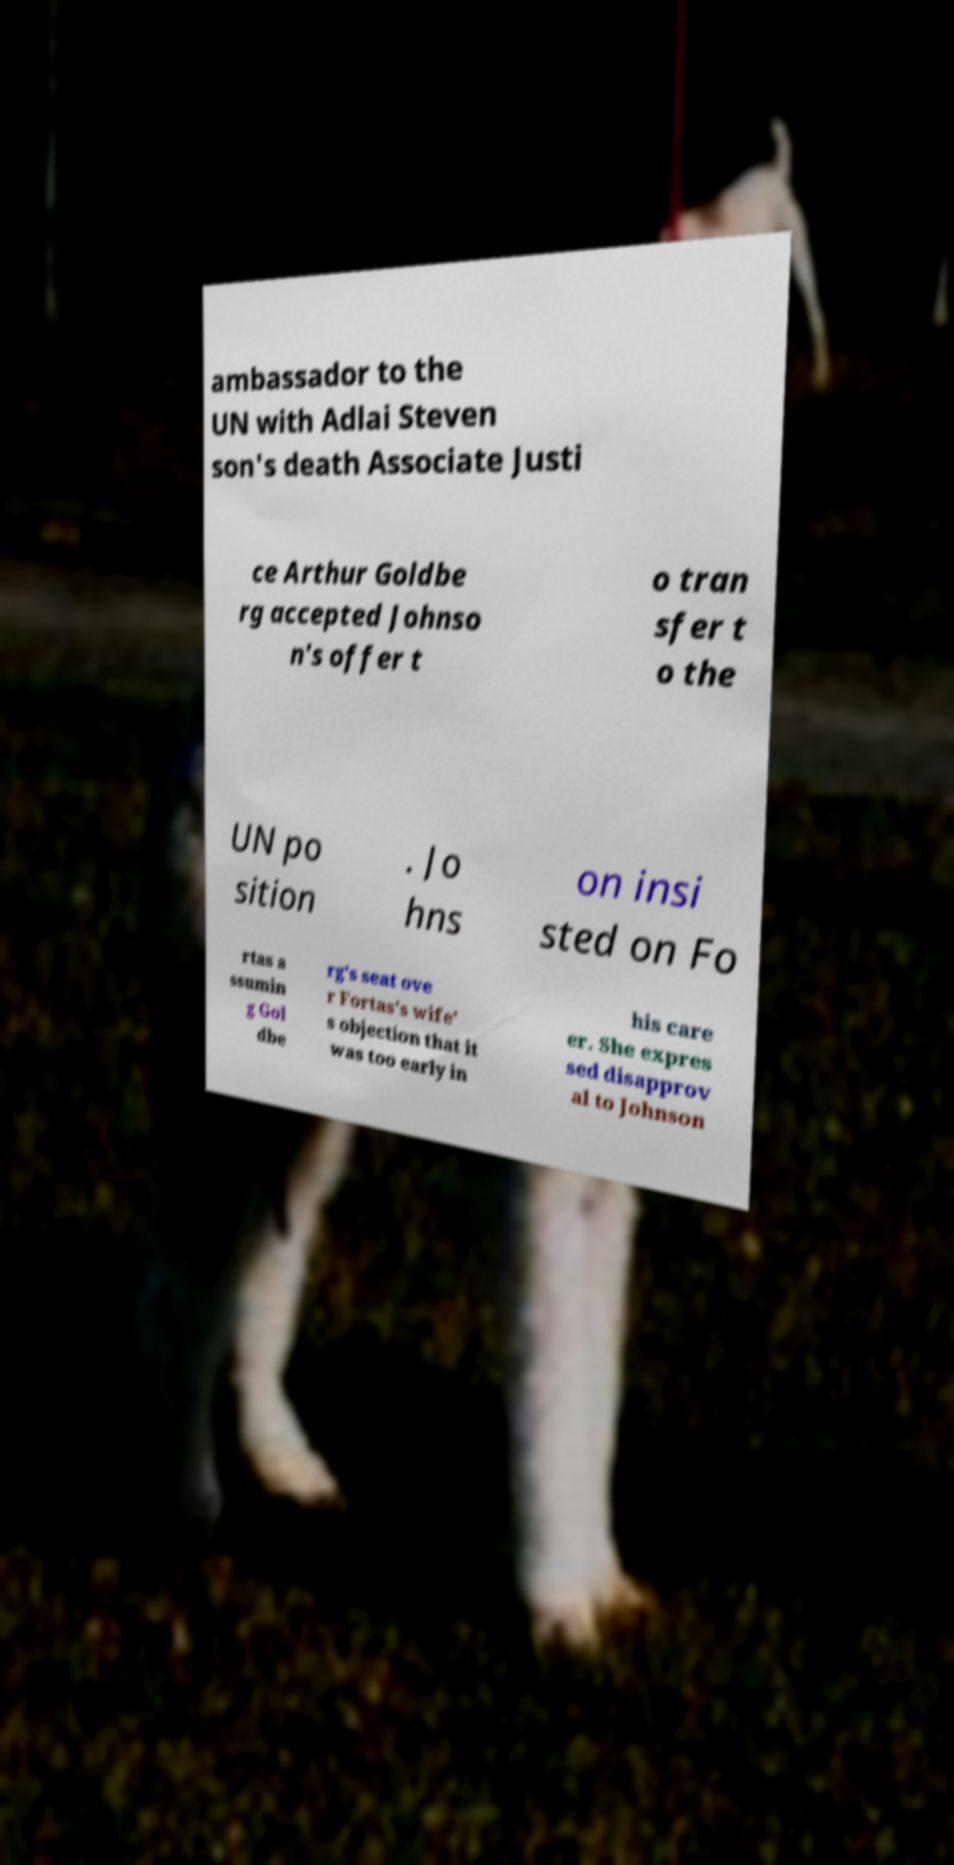For documentation purposes, I need the text within this image transcribed. Could you provide that? ambassador to the UN with Adlai Steven son's death Associate Justi ce Arthur Goldbe rg accepted Johnso n's offer t o tran sfer t o the UN po sition . Jo hns on insi sted on Fo rtas a ssumin g Gol dbe rg's seat ove r Fortas's wife' s objection that it was too early in his care er. She expres sed disapprov al to Johnson 